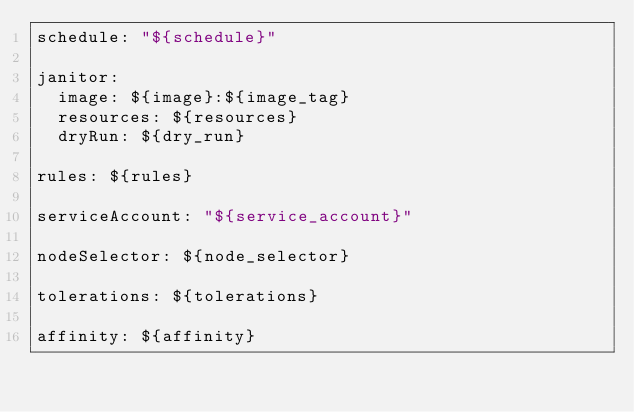<code> <loc_0><loc_0><loc_500><loc_500><_YAML_>schedule: "${schedule}"

janitor:
  image: ${image}:${image_tag}
  resources: ${resources}
  dryRun: ${dry_run}

rules: ${rules}

serviceAccount: "${service_account}"

nodeSelector: ${node_selector}

tolerations: ${tolerations}

affinity: ${affinity}
</code> 